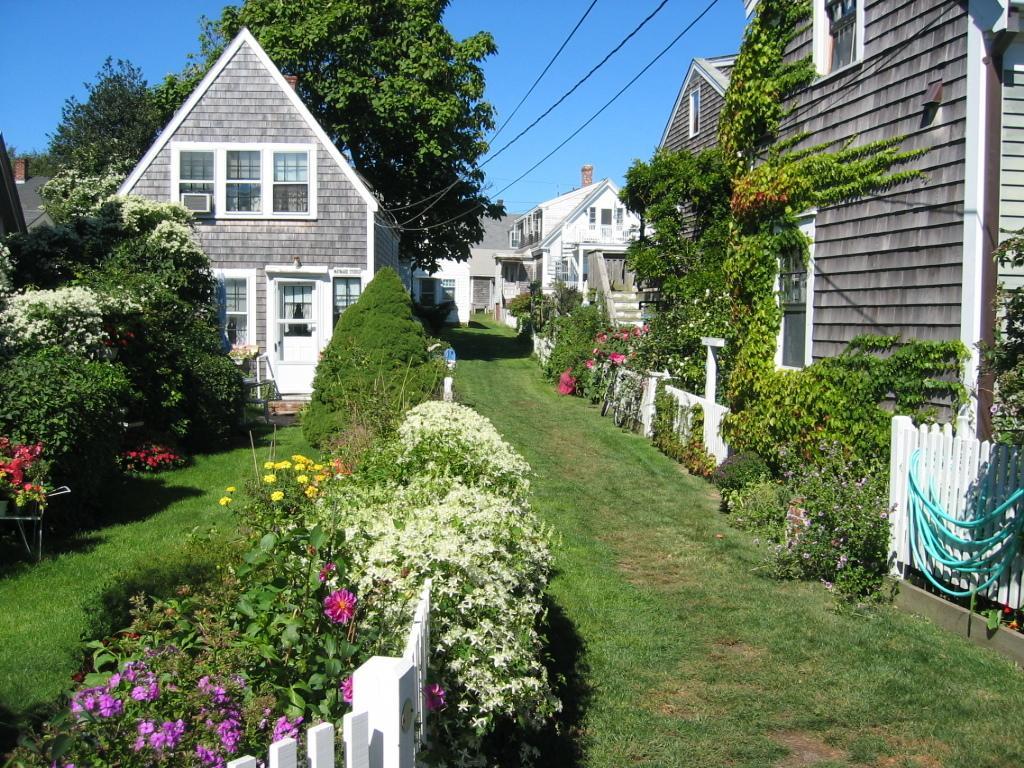Please provide a concise description of this image. In this picture I can see plants with flowers, there is grass, fence, there are houses, trees, cables, and in the background there is sky. 